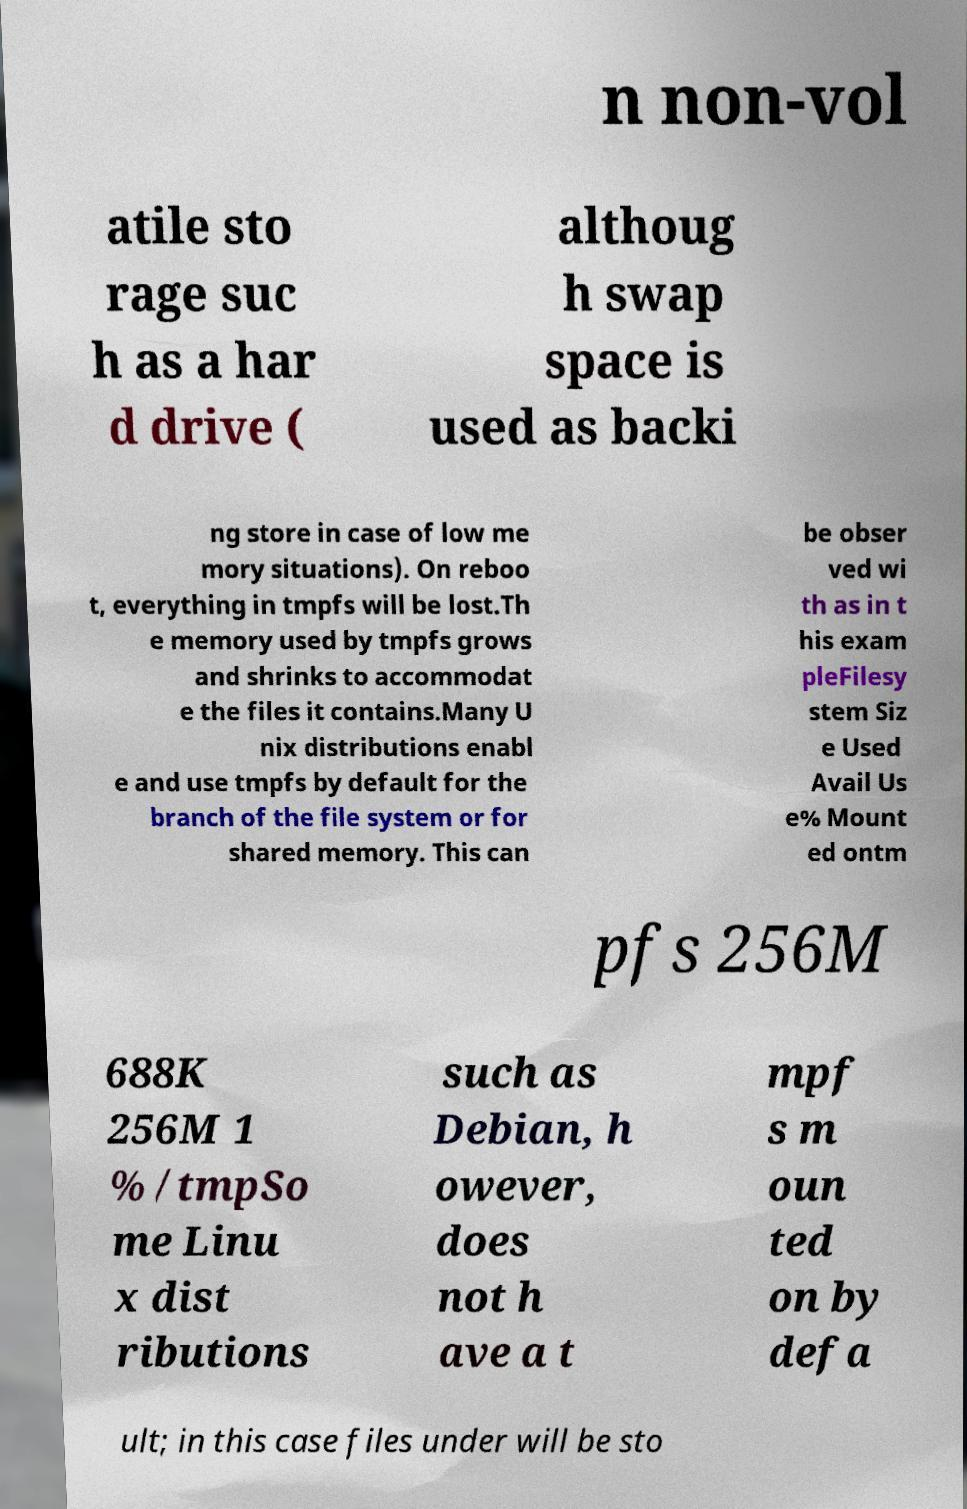Please identify and transcribe the text found in this image. n non-vol atile sto rage suc h as a har d drive ( althoug h swap space is used as backi ng store in case of low me mory situations). On reboo t, everything in tmpfs will be lost.Th e memory used by tmpfs grows and shrinks to accommodat e the files it contains.Many U nix distributions enabl e and use tmpfs by default for the branch of the file system or for shared memory. This can be obser ved wi th as in t his exam pleFilesy stem Siz e Used Avail Us e% Mount ed ontm pfs 256M 688K 256M 1 % /tmpSo me Linu x dist ributions such as Debian, h owever, does not h ave a t mpf s m oun ted on by defa ult; in this case files under will be sto 